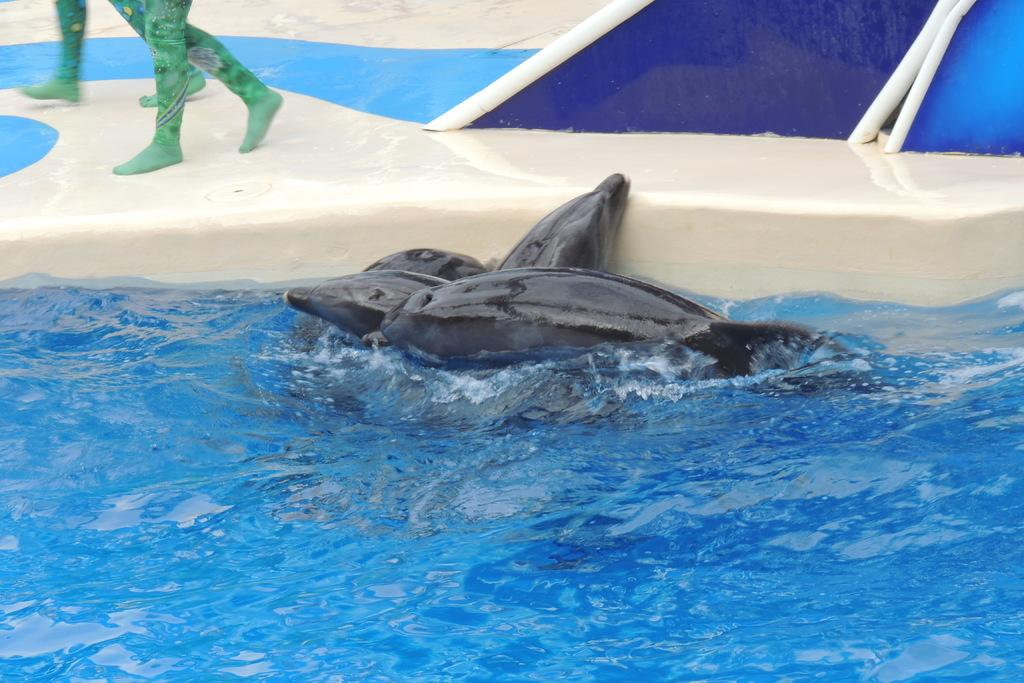What animals can be seen in the water in the image? There are dolphins in the water in the image. What are the two people in the background doing? The two people in the background are walking on a platform. Can you see a basketball being played by the dolphins in the image? There is no basketball or any indication of a game being played in the image; it features dolphins in the water and two people walking on a platform. What type of stitch is being used to sew the dolphins in the image? There are no stitches or any indication of sewing in the image; it is a photograph or illustration of dolphins in the water and two people walking on a platform. 